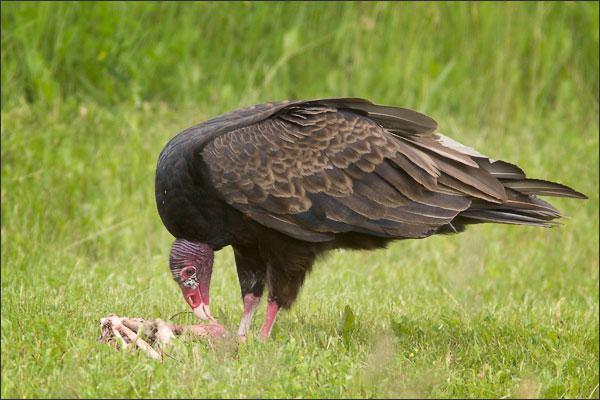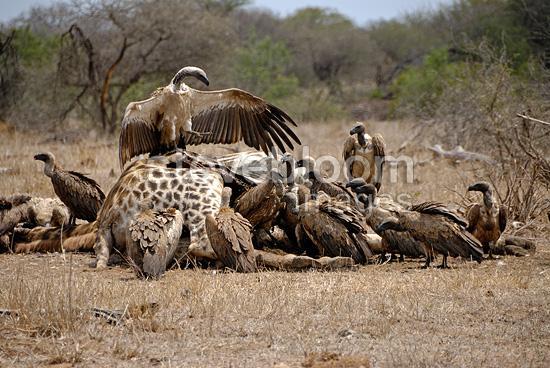The first image is the image on the left, the second image is the image on the right. Given the left and right images, does the statement "There are two vultures eating in the images." hold true? Answer yes or no. No. The first image is the image on the left, the second image is the image on the right. Examine the images to the left and right. Is the description "in the right side pic the bird has something it its mouth" accurate? Answer yes or no. No. 